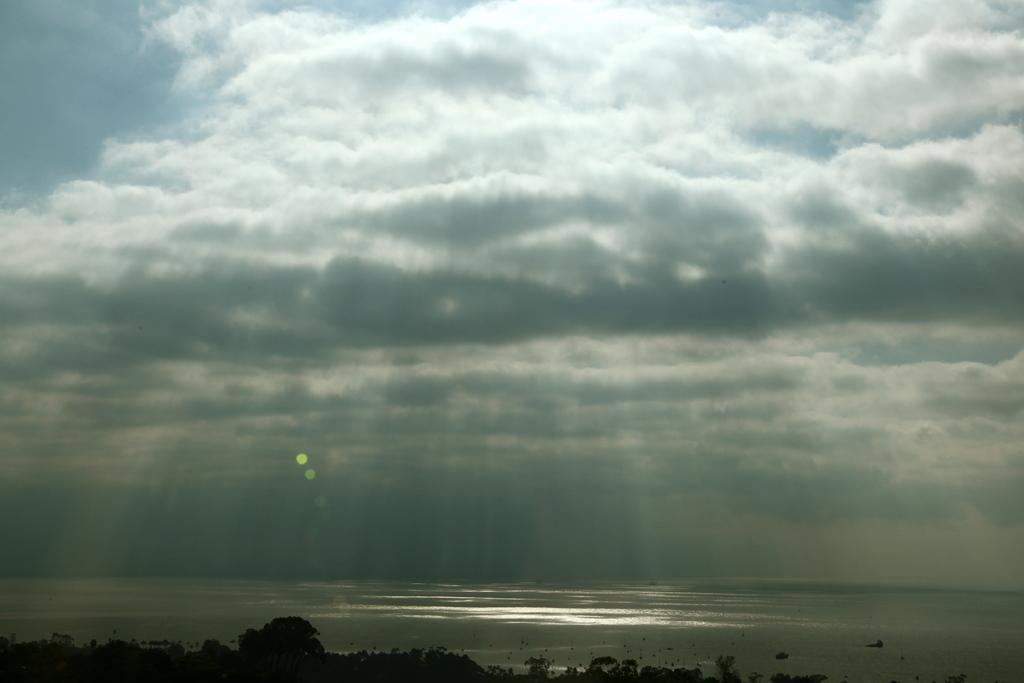What type of vegetation can be seen in the image? There are trees in the image. What is located at the bottom of the image? There is water at the bottom of the image. What part of the natural environment is visible in the image? The sky is visible at the top of the image. Where is the shop located in the image? There is no shop present in the image. What type of waste can be seen in the water at the bottom of the image? There is no waste visible in the water at the bottom of the image. 